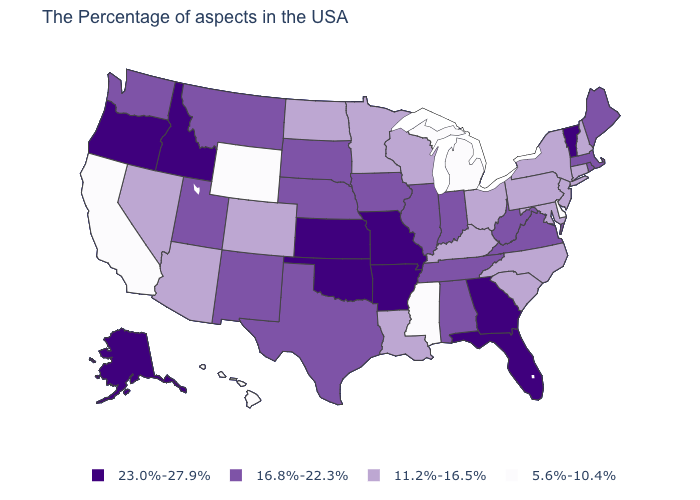Does Washington have a lower value than Vermont?
Concise answer only. Yes. What is the lowest value in the MidWest?
Write a very short answer. 5.6%-10.4%. How many symbols are there in the legend?
Give a very brief answer. 4. What is the value of North Carolina?
Give a very brief answer. 11.2%-16.5%. Does Oregon have the highest value in the USA?
Concise answer only. Yes. What is the value of Maryland?
Concise answer only. 11.2%-16.5%. Among the states that border Minnesota , which have the lowest value?
Write a very short answer. Wisconsin, North Dakota. Among the states that border Florida , which have the highest value?
Concise answer only. Georgia. Among the states that border Connecticut , which have the highest value?
Give a very brief answer. Massachusetts, Rhode Island. Which states have the lowest value in the USA?
Quick response, please. Delaware, Michigan, Mississippi, Wyoming, California, Hawaii. What is the highest value in the West ?
Answer briefly. 23.0%-27.9%. Which states hav the highest value in the South?
Answer briefly. Florida, Georgia, Arkansas, Oklahoma. Name the states that have a value in the range 23.0%-27.9%?
Keep it brief. Vermont, Florida, Georgia, Missouri, Arkansas, Kansas, Oklahoma, Idaho, Oregon, Alaska. What is the lowest value in states that border Minnesota?
Answer briefly. 11.2%-16.5%. 